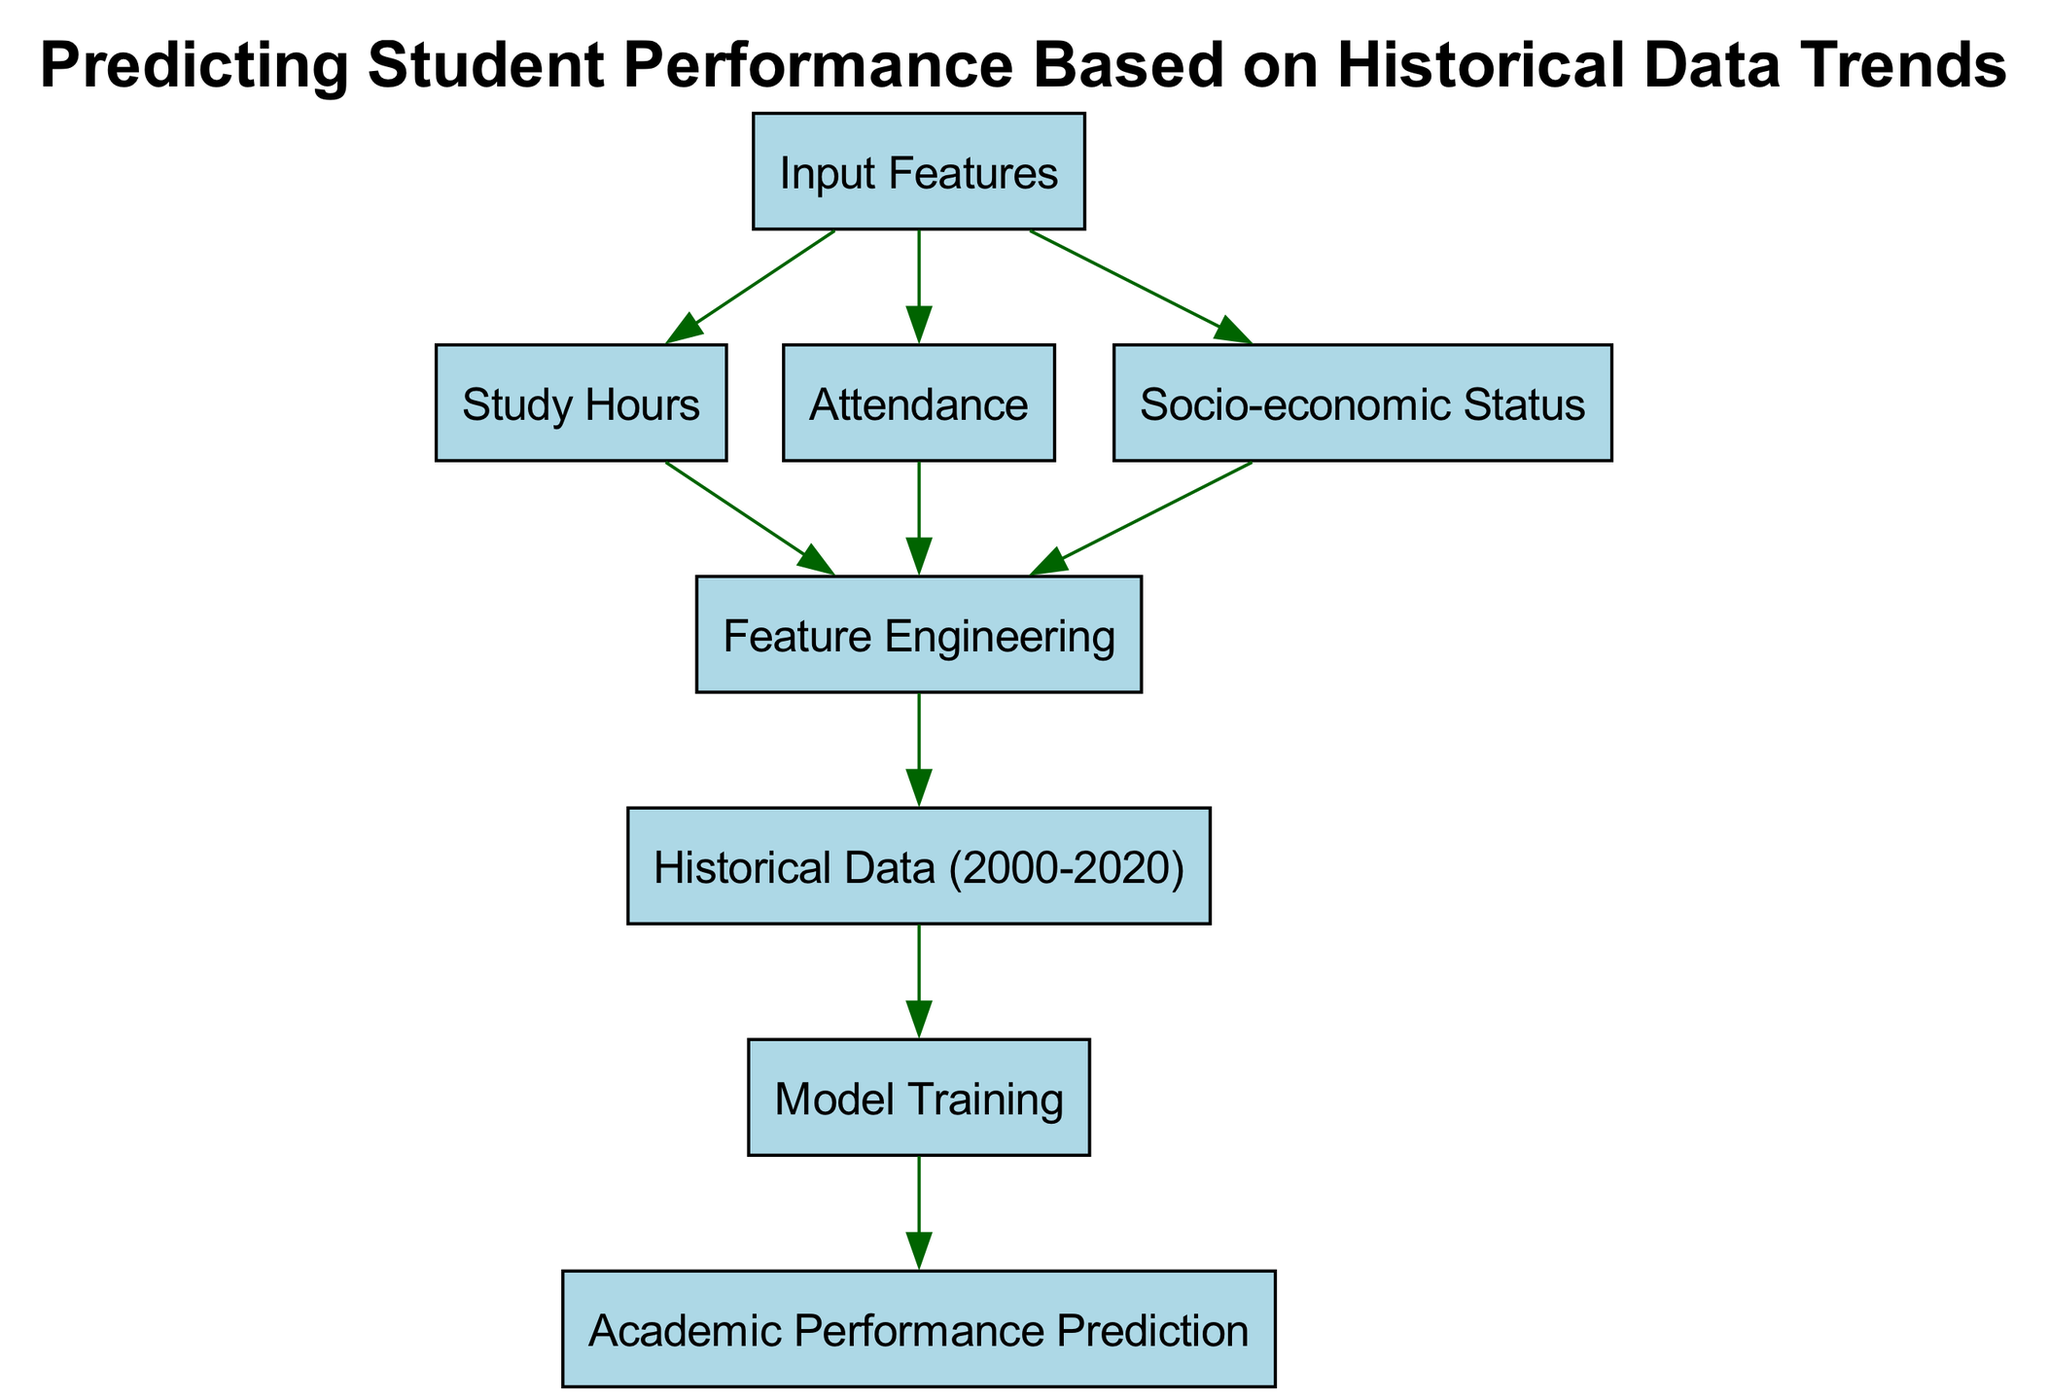What are the input features in the diagram? The input features represented in the diagram include study hours, attendance, and socio-economic status, which are linked to the node labeled "Input Features."
Answer: Study Hours, Attendance, Socio-economic Status How many nodes are in the diagram? The diagram contains a total of eight nodes, which include the inputs, processing steps, and output predictions.
Answer: Eight Which node follows the "feature engineering" node in the flow? The "historical data" node follows the "feature engineering" node indicating the next step in the prediction process.
Answer: Historical Data What type of model is used for academic performance prediction? The model used is indicated to be part of a predictive process that focuses on predicting academic performance based on historical data trends.
Answer: Predictive Model Which input feature is connected directly to the "feature engineering" node? Both study hours, attendance, and socio-economic status are directly connected to the feature engineering node, which processes these inputs.
Answer: Study Hours, Attendance, Socio-economic Status How does the diagram demonstrate the relationship between historical data and model training? The flow from the "historical data" node to the "model training" node shows that historical data informs the model training process for making predictions.
Answer: It informs model training What is the final output of the process shown in the diagram? The final output of the process is indicated by the "performance prediction" node, representing the result of the model training and feature engineering.
Answer: Academic Performance Prediction What is the starting point of the data flow in the diagram? The starting point of the data flow is the "input features" node, which marks where the various input features are initially assessed.
Answer: Input Features How many edges are leading from the "input features" node? Three edges lead from the "input features" node, each linking to different input features such as study hours, attendance, and socio-economic status.
Answer: Three 